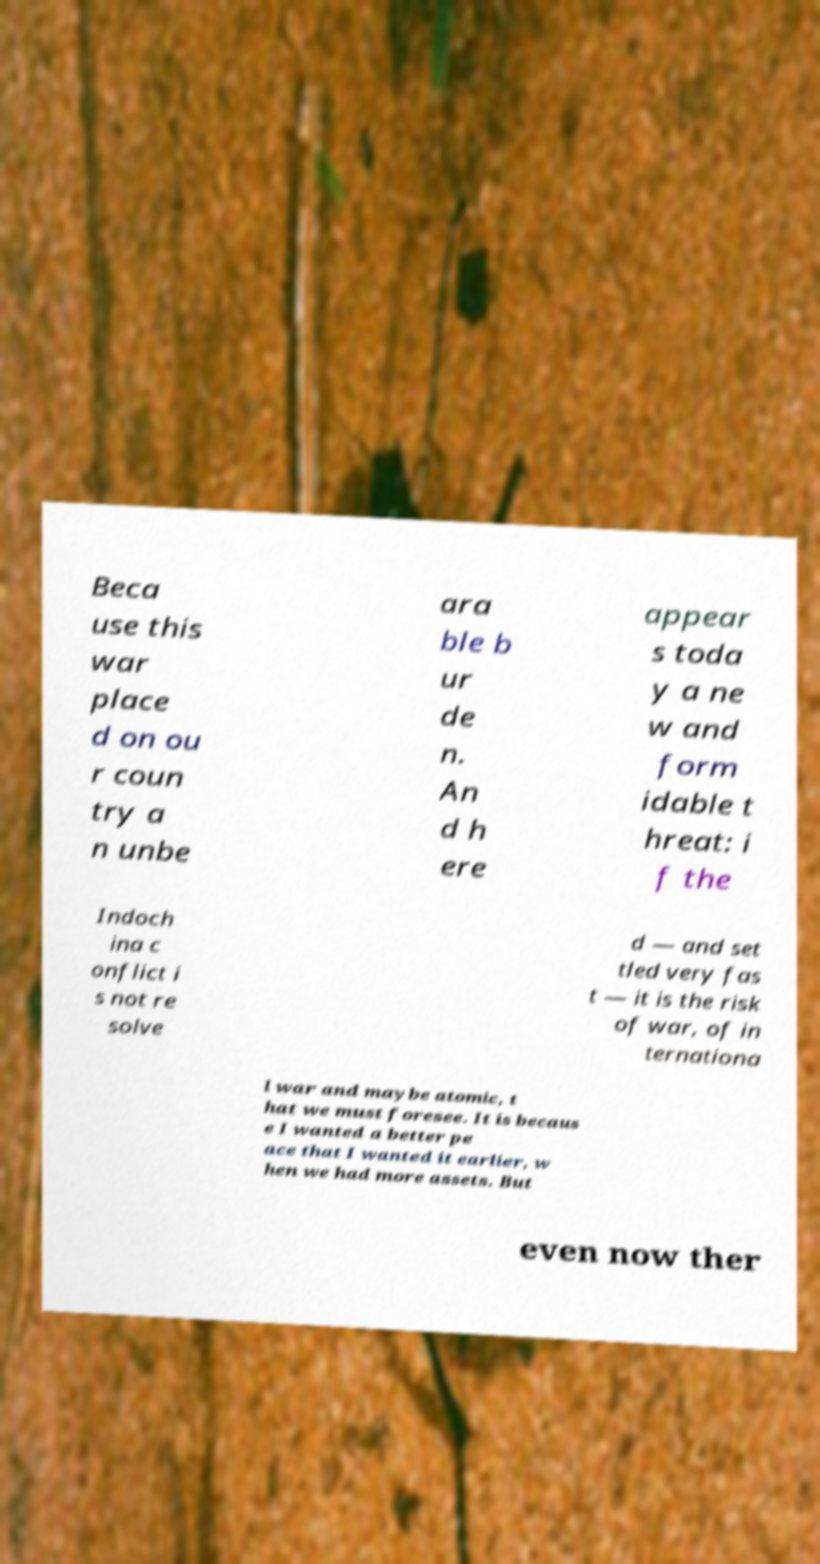Could you extract and type out the text from this image? Beca use this war place d on ou r coun try a n unbe ara ble b ur de n. An d h ere appear s toda y a ne w and form idable t hreat: i f the Indoch ina c onflict i s not re solve d — and set tled very fas t — it is the risk of war, of in ternationa l war and maybe atomic, t hat we must foresee. It is becaus e I wanted a better pe ace that I wanted it earlier, w hen we had more assets. But even now ther 